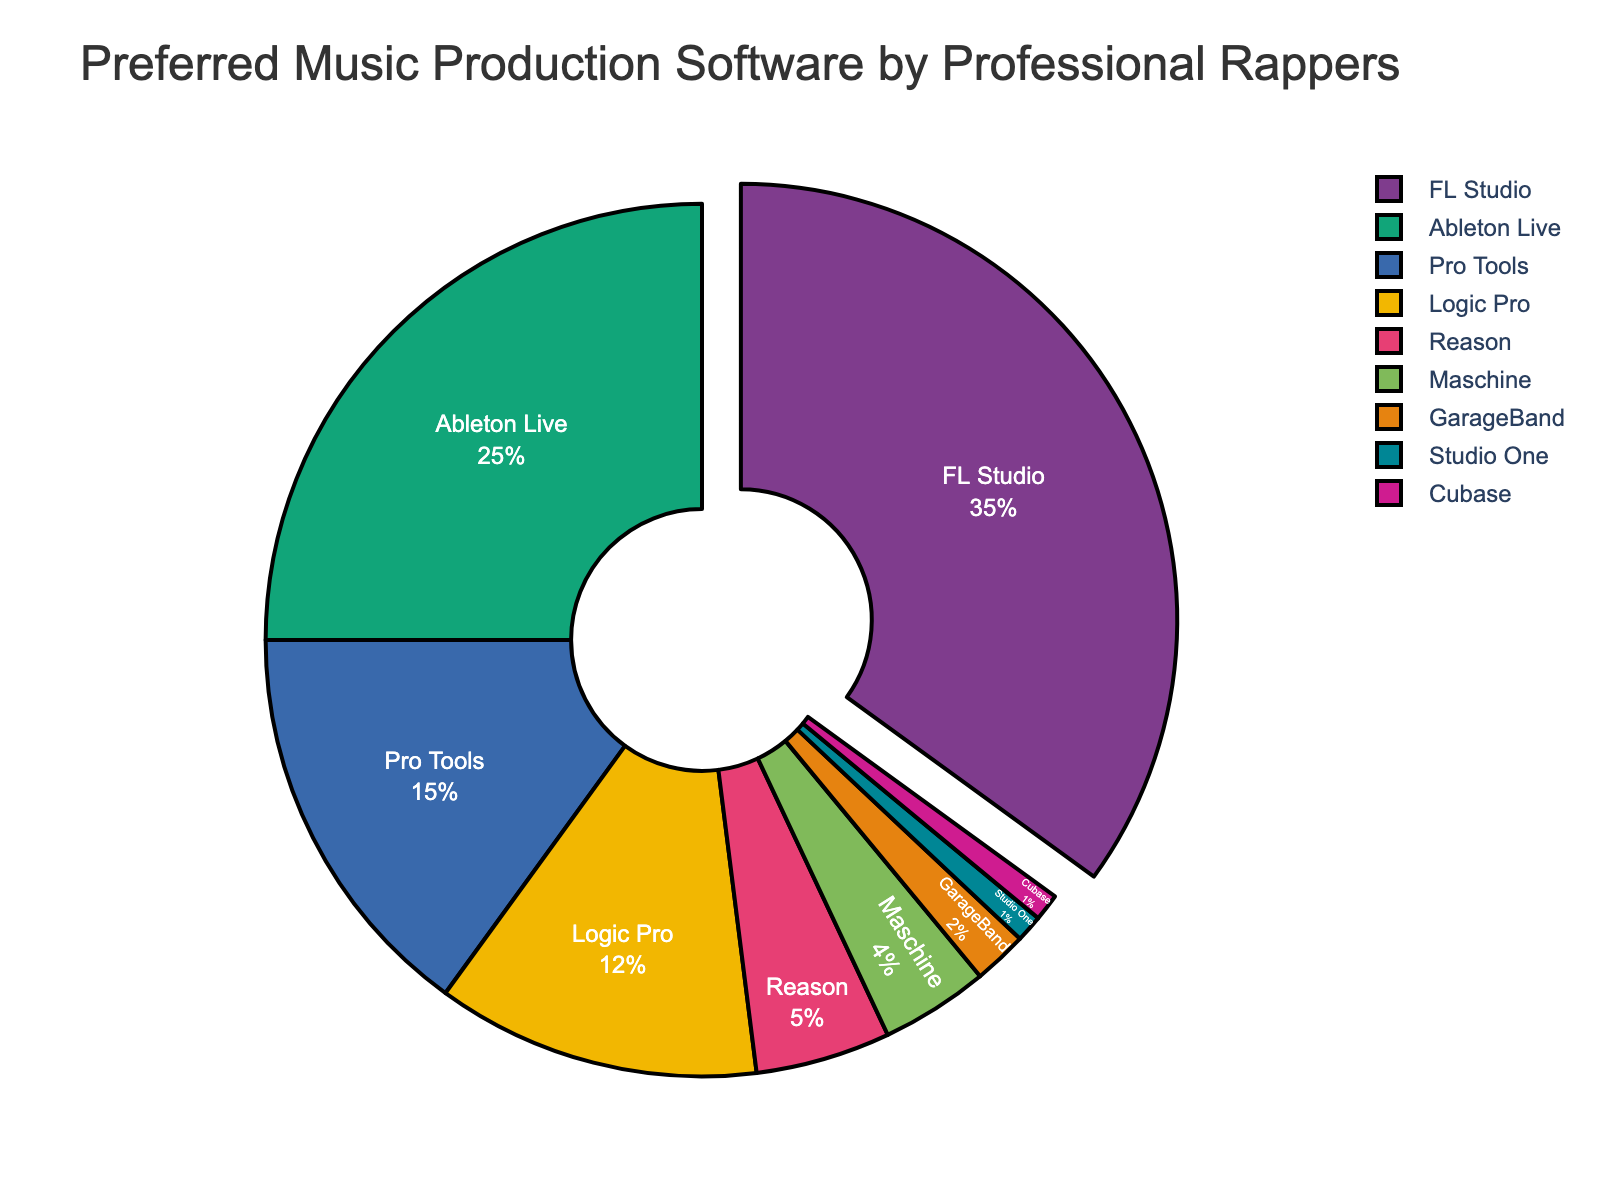What percentage of professional rappers prefer FL Studio over Ableton Live? From the pie chart, FL Studio is used by 35% of professional rappers, while Ableton Live is used by 25%. The difference is calculated as 35% - 25% = 10%.
Answer: 10% What is the combined percentage for GarageBand and Cubase? The pie chart shows GarageBand with 2% and Cubase with 1%. The combined percentage is 2% + 1% = 3%.
Answer: 3% Which software is preferred by exactly half the percentage of rappers compared to Pro Tools? Pro Tools has a 15% preference among professional rappers. Half of 15% is 7.5%. Reason is used by 5%, which is closest though not exactly half. None exactly match 7.5%.
Answer: None Is the percentage of rappers using FL Studio more than the combined percentage of those using Logic Pro and Maschine? FL Studio is used by 35% of rappers. Logic Pro is used by 12% and Maschine by 4%. The combined percentage for Logic Pro and Maschine is 12% + 4% = 16%. Since 35% > 16%, FL Studio is indeed used by a higher percentage.
Answer: Yes Rank the top three most preferred music production software according to the chart. From the pie chart, the top three software preferences are ranked by percentage: FL Studio (35%), Ableton Live (25%), and Pro Tools (15%).
Answer: FL Studio, Ableton Live, Pro Tools What is the percentage of rappers that do not use either Ableton Live or FL Studio? The chart shows Ableton Live at 25% and FL Studio at 35%. To find the percentage of rappers not using either, subtract the combined percentage from 100%: 100% - (35% + 25%) = 40%.
Answer: 40% Which software has nearly triple the percentage of users compared to Reason? Reason is used by 5% of rappers. Triple 5% is 15%. Pro Tools is used by 15%, which is exactly triple compared to Reason.
Answer: Pro Tools What is the ratio of rappers using FL Studio to those using Maschine? FL Studio is used by 35% of rappers, while Maschine is used by 4%. The ratio is calculated as 35/4, which simplifies to 35:4.
Answer: 35:4 